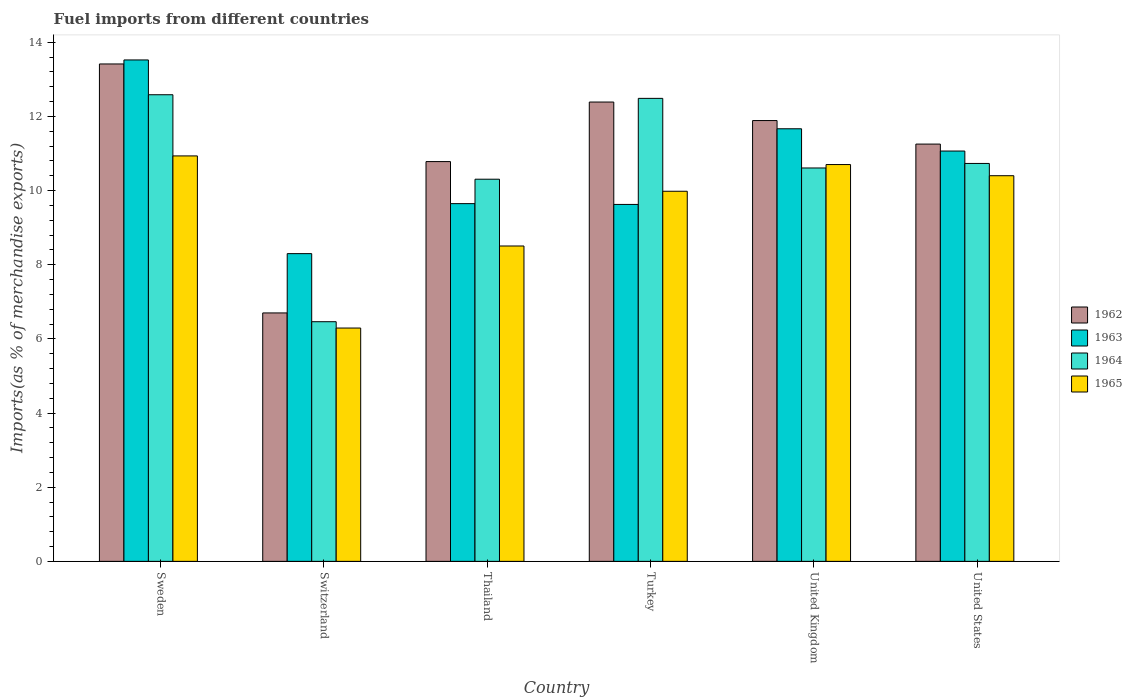How many different coloured bars are there?
Your response must be concise. 4. Are the number of bars per tick equal to the number of legend labels?
Keep it short and to the point. Yes. Are the number of bars on each tick of the X-axis equal?
Offer a terse response. Yes. How many bars are there on the 4th tick from the left?
Provide a short and direct response. 4. What is the label of the 6th group of bars from the left?
Your response must be concise. United States. What is the percentage of imports to different countries in 1965 in Turkey?
Keep it short and to the point. 9.98. Across all countries, what is the maximum percentage of imports to different countries in 1965?
Ensure brevity in your answer.  10.93. Across all countries, what is the minimum percentage of imports to different countries in 1964?
Offer a terse response. 6.46. In which country was the percentage of imports to different countries in 1962 minimum?
Offer a terse response. Switzerland. What is the total percentage of imports to different countries in 1964 in the graph?
Offer a terse response. 63.18. What is the difference between the percentage of imports to different countries in 1964 in Switzerland and that in Turkey?
Provide a short and direct response. -6.02. What is the difference between the percentage of imports to different countries in 1964 in Thailand and the percentage of imports to different countries in 1965 in United States?
Your answer should be compact. -0.09. What is the average percentage of imports to different countries in 1963 per country?
Your answer should be compact. 10.64. What is the difference between the percentage of imports to different countries of/in 1962 and percentage of imports to different countries of/in 1965 in Turkey?
Provide a succinct answer. 2.41. What is the ratio of the percentage of imports to different countries in 1962 in Switzerland to that in Turkey?
Provide a short and direct response. 0.54. Is the difference between the percentage of imports to different countries in 1962 in United Kingdom and United States greater than the difference between the percentage of imports to different countries in 1965 in United Kingdom and United States?
Make the answer very short. Yes. What is the difference between the highest and the second highest percentage of imports to different countries in 1965?
Give a very brief answer. -0.53. What is the difference between the highest and the lowest percentage of imports to different countries in 1962?
Your answer should be very brief. 6.72. Is the sum of the percentage of imports to different countries in 1965 in Sweden and United Kingdom greater than the maximum percentage of imports to different countries in 1963 across all countries?
Keep it short and to the point. Yes. What does the 2nd bar from the right in Thailand represents?
Give a very brief answer. 1964. Is it the case that in every country, the sum of the percentage of imports to different countries in 1964 and percentage of imports to different countries in 1965 is greater than the percentage of imports to different countries in 1963?
Offer a very short reply. Yes. How many bars are there?
Offer a terse response. 24. How many countries are there in the graph?
Give a very brief answer. 6. Are the values on the major ticks of Y-axis written in scientific E-notation?
Provide a short and direct response. No. Does the graph contain any zero values?
Your answer should be compact. No. Does the graph contain grids?
Ensure brevity in your answer.  No. How are the legend labels stacked?
Provide a short and direct response. Vertical. What is the title of the graph?
Provide a succinct answer. Fuel imports from different countries. Does "1997" appear as one of the legend labels in the graph?
Keep it short and to the point. No. What is the label or title of the X-axis?
Give a very brief answer. Country. What is the label or title of the Y-axis?
Your answer should be very brief. Imports(as % of merchandise exports). What is the Imports(as % of merchandise exports) of 1962 in Sweden?
Your response must be concise. 13.42. What is the Imports(as % of merchandise exports) in 1963 in Sweden?
Make the answer very short. 13.52. What is the Imports(as % of merchandise exports) in 1964 in Sweden?
Offer a very short reply. 12.58. What is the Imports(as % of merchandise exports) of 1965 in Sweden?
Offer a terse response. 10.93. What is the Imports(as % of merchandise exports) in 1962 in Switzerland?
Keep it short and to the point. 6.7. What is the Imports(as % of merchandise exports) of 1963 in Switzerland?
Ensure brevity in your answer.  8.3. What is the Imports(as % of merchandise exports) in 1964 in Switzerland?
Your answer should be very brief. 6.46. What is the Imports(as % of merchandise exports) in 1965 in Switzerland?
Provide a succinct answer. 6.29. What is the Imports(as % of merchandise exports) of 1962 in Thailand?
Provide a succinct answer. 10.78. What is the Imports(as % of merchandise exports) in 1963 in Thailand?
Your response must be concise. 9.65. What is the Imports(as % of merchandise exports) of 1964 in Thailand?
Your response must be concise. 10.31. What is the Imports(as % of merchandise exports) in 1965 in Thailand?
Ensure brevity in your answer.  8.51. What is the Imports(as % of merchandise exports) in 1962 in Turkey?
Keep it short and to the point. 12.39. What is the Imports(as % of merchandise exports) in 1963 in Turkey?
Offer a very short reply. 9.63. What is the Imports(as % of merchandise exports) of 1964 in Turkey?
Offer a terse response. 12.49. What is the Imports(as % of merchandise exports) of 1965 in Turkey?
Offer a very short reply. 9.98. What is the Imports(as % of merchandise exports) in 1962 in United Kingdom?
Offer a very short reply. 11.89. What is the Imports(as % of merchandise exports) of 1963 in United Kingdom?
Your response must be concise. 11.67. What is the Imports(as % of merchandise exports) of 1964 in United Kingdom?
Provide a succinct answer. 10.61. What is the Imports(as % of merchandise exports) in 1965 in United Kingdom?
Offer a very short reply. 10.7. What is the Imports(as % of merchandise exports) in 1962 in United States?
Your answer should be very brief. 11.25. What is the Imports(as % of merchandise exports) of 1963 in United States?
Your answer should be very brief. 11.07. What is the Imports(as % of merchandise exports) of 1964 in United States?
Make the answer very short. 10.73. What is the Imports(as % of merchandise exports) in 1965 in United States?
Offer a very short reply. 10.4. Across all countries, what is the maximum Imports(as % of merchandise exports) in 1962?
Provide a short and direct response. 13.42. Across all countries, what is the maximum Imports(as % of merchandise exports) of 1963?
Provide a short and direct response. 13.52. Across all countries, what is the maximum Imports(as % of merchandise exports) of 1964?
Make the answer very short. 12.58. Across all countries, what is the maximum Imports(as % of merchandise exports) in 1965?
Provide a succinct answer. 10.93. Across all countries, what is the minimum Imports(as % of merchandise exports) in 1962?
Give a very brief answer. 6.7. Across all countries, what is the minimum Imports(as % of merchandise exports) of 1963?
Provide a succinct answer. 8.3. Across all countries, what is the minimum Imports(as % of merchandise exports) in 1964?
Give a very brief answer. 6.46. Across all countries, what is the minimum Imports(as % of merchandise exports) of 1965?
Provide a short and direct response. 6.29. What is the total Imports(as % of merchandise exports) of 1962 in the graph?
Offer a terse response. 66.43. What is the total Imports(as % of merchandise exports) in 1963 in the graph?
Ensure brevity in your answer.  63.83. What is the total Imports(as % of merchandise exports) of 1964 in the graph?
Offer a terse response. 63.18. What is the total Imports(as % of merchandise exports) in 1965 in the graph?
Offer a very short reply. 56.82. What is the difference between the Imports(as % of merchandise exports) of 1962 in Sweden and that in Switzerland?
Give a very brief answer. 6.72. What is the difference between the Imports(as % of merchandise exports) of 1963 in Sweden and that in Switzerland?
Make the answer very short. 5.22. What is the difference between the Imports(as % of merchandise exports) of 1964 in Sweden and that in Switzerland?
Give a very brief answer. 6.12. What is the difference between the Imports(as % of merchandise exports) in 1965 in Sweden and that in Switzerland?
Your response must be concise. 4.64. What is the difference between the Imports(as % of merchandise exports) in 1962 in Sweden and that in Thailand?
Keep it short and to the point. 2.63. What is the difference between the Imports(as % of merchandise exports) in 1963 in Sweden and that in Thailand?
Your response must be concise. 3.88. What is the difference between the Imports(as % of merchandise exports) in 1964 in Sweden and that in Thailand?
Offer a terse response. 2.28. What is the difference between the Imports(as % of merchandise exports) of 1965 in Sweden and that in Thailand?
Provide a short and direct response. 2.43. What is the difference between the Imports(as % of merchandise exports) of 1962 in Sweden and that in Turkey?
Your response must be concise. 1.03. What is the difference between the Imports(as % of merchandise exports) in 1963 in Sweden and that in Turkey?
Your answer should be very brief. 3.9. What is the difference between the Imports(as % of merchandise exports) in 1964 in Sweden and that in Turkey?
Your response must be concise. 0.1. What is the difference between the Imports(as % of merchandise exports) in 1965 in Sweden and that in Turkey?
Your response must be concise. 0.95. What is the difference between the Imports(as % of merchandise exports) in 1962 in Sweden and that in United Kingdom?
Offer a terse response. 1.53. What is the difference between the Imports(as % of merchandise exports) in 1963 in Sweden and that in United Kingdom?
Offer a very short reply. 1.86. What is the difference between the Imports(as % of merchandise exports) of 1964 in Sweden and that in United Kingdom?
Your answer should be compact. 1.97. What is the difference between the Imports(as % of merchandise exports) in 1965 in Sweden and that in United Kingdom?
Make the answer very short. 0.23. What is the difference between the Imports(as % of merchandise exports) of 1962 in Sweden and that in United States?
Keep it short and to the point. 2.16. What is the difference between the Imports(as % of merchandise exports) in 1963 in Sweden and that in United States?
Your response must be concise. 2.46. What is the difference between the Imports(as % of merchandise exports) of 1964 in Sweden and that in United States?
Offer a terse response. 1.85. What is the difference between the Imports(as % of merchandise exports) of 1965 in Sweden and that in United States?
Your answer should be compact. 0.53. What is the difference between the Imports(as % of merchandise exports) in 1962 in Switzerland and that in Thailand?
Your answer should be very brief. -4.08. What is the difference between the Imports(as % of merchandise exports) in 1963 in Switzerland and that in Thailand?
Keep it short and to the point. -1.35. What is the difference between the Imports(as % of merchandise exports) in 1964 in Switzerland and that in Thailand?
Your answer should be very brief. -3.84. What is the difference between the Imports(as % of merchandise exports) of 1965 in Switzerland and that in Thailand?
Provide a short and direct response. -2.21. What is the difference between the Imports(as % of merchandise exports) in 1962 in Switzerland and that in Turkey?
Your answer should be very brief. -5.69. What is the difference between the Imports(as % of merchandise exports) of 1963 in Switzerland and that in Turkey?
Your answer should be compact. -1.33. What is the difference between the Imports(as % of merchandise exports) of 1964 in Switzerland and that in Turkey?
Your response must be concise. -6.02. What is the difference between the Imports(as % of merchandise exports) of 1965 in Switzerland and that in Turkey?
Your answer should be compact. -3.69. What is the difference between the Imports(as % of merchandise exports) of 1962 in Switzerland and that in United Kingdom?
Provide a short and direct response. -5.19. What is the difference between the Imports(as % of merchandise exports) in 1963 in Switzerland and that in United Kingdom?
Give a very brief answer. -3.37. What is the difference between the Imports(as % of merchandise exports) in 1964 in Switzerland and that in United Kingdom?
Make the answer very short. -4.15. What is the difference between the Imports(as % of merchandise exports) of 1965 in Switzerland and that in United Kingdom?
Offer a terse response. -4.41. What is the difference between the Imports(as % of merchandise exports) of 1962 in Switzerland and that in United States?
Your response must be concise. -4.55. What is the difference between the Imports(as % of merchandise exports) in 1963 in Switzerland and that in United States?
Ensure brevity in your answer.  -2.77. What is the difference between the Imports(as % of merchandise exports) of 1964 in Switzerland and that in United States?
Provide a short and direct response. -4.27. What is the difference between the Imports(as % of merchandise exports) of 1965 in Switzerland and that in United States?
Ensure brevity in your answer.  -4.11. What is the difference between the Imports(as % of merchandise exports) in 1962 in Thailand and that in Turkey?
Offer a very short reply. -1.61. What is the difference between the Imports(as % of merchandise exports) of 1963 in Thailand and that in Turkey?
Make the answer very short. 0.02. What is the difference between the Imports(as % of merchandise exports) of 1964 in Thailand and that in Turkey?
Ensure brevity in your answer.  -2.18. What is the difference between the Imports(as % of merchandise exports) in 1965 in Thailand and that in Turkey?
Provide a short and direct response. -1.48. What is the difference between the Imports(as % of merchandise exports) in 1962 in Thailand and that in United Kingdom?
Your response must be concise. -1.11. What is the difference between the Imports(as % of merchandise exports) in 1963 in Thailand and that in United Kingdom?
Offer a terse response. -2.02. What is the difference between the Imports(as % of merchandise exports) in 1964 in Thailand and that in United Kingdom?
Provide a short and direct response. -0.3. What is the difference between the Imports(as % of merchandise exports) of 1965 in Thailand and that in United Kingdom?
Ensure brevity in your answer.  -2.2. What is the difference between the Imports(as % of merchandise exports) of 1962 in Thailand and that in United States?
Offer a terse response. -0.47. What is the difference between the Imports(as % of merchandise exports) in 1963 in Thailand and that in United States?
Make the answer very short. -1.42. What is the difference between the Imports(as % of merchandise exports) in 1964 in Thailand and that in United States?
Offer a very short reply. -0.42. What is the difference between the Imports(as % of merchandise exports) of 1965 in Thailand and that in United States?
Provide a short and direct response. -1.9. What is the difference between the Imports(as % of merchandise exports) of 1962 in Turkey and that in United Kingdom?
Provide a succinct answer. 0.5. What is the difference between the Imports(as % of merchandise exports) of 1963 in Turkey and that in United Kingdom?
Make the answer very short. -2.04. What is the difference between the Imports(as % of merchandise exports) of 1964 in Turkey and that in United Kingdom?
Ensure brevity in your answer.  1.88. What is the difference between the Imports(as % of merchandise exports) in 1965 in Turkey and that in United Kingdom?
Your answer should be compact. -0.72. What is the difference between the Imports(as % of merchandise exports) in 1962 in Turkey and that in United States?
Give a very brief answer. 1.13. What is the difference between the Imports(as % of merchandise exports) in 1963 in Turkey and that in United States?
Your answer should be very brief. -1.44. What is the difference between the Imports(as % of merchandise exports) in 1964 in Turkey and that in United States?
Keep it short and to the point. 1.76. What is the difference between the Imports(as % of merchandise exports) of 1965 in Turkey and that in United States?
Your response must be concise. -0.42. What is the difference between the Imports(as % of merchandise exports) of 1962 in United Kingdom and that in United States?
Provide a succinct answer. 0.63. What is the difference between the Imports(as % of merchandise exports) in 1963 in United Kingdom and that in United States?
Offer a terse response. 0.6. What is the difference between the Imports(as % of merchandise exports) of 1964 in United Kingdom and that in United States?
Ensure brevity in your answer.  -0.12. What is the difference between the Imports(as % of merchandise exports) of 1965 in United Kingdom and that in United States?
Provide a short and direct response. 0.3. What is the difference between the Imports(as % of merchandise exports) of 1962 in Sweden and the Imports(as % of merchandise exports) of 1963 in Switzerland?
Make the answer very short. 5.12. What is the difference between the Imports(as % of merchandise exports) in 1962 in Sweden and the Imports(as % of merchandise exports) in 1964 in Switzerland?
Keep it short and to the point. 6.95. What is the difference between the Imports(as % of merchandise exports) in 1962 in Sweden and the Imports(as % of merchandise exports) in 1965 in Switzerland?
Make the answer very short. 7.12. What is the difference between the Imports(as % of merchandise exports) of 1963 in Sweden and the Imports(as % of merchandise exports) of 1964 in Switzerland?
Give a very brief answer. 7.06. What is the difference between the Imports(as % of merchandise exports) of 1963 in Sweden and the Imports(as % of merchandise exports) of 1965 in Switzerland?
Provide a succinct answer. 7.23. What is the difference between the Imports(as % of merchandise exports) in 1964 in Sweden and the Imports(as % of merchandise exports) in 1965 in Switzerland?
Your answer should be compact. 6.29. What is the difference between the Imports(as % of merchandise exports) of 1962 in Sweden and the Imports(as % of merchandise exports) of 1963 in Thailand?
Provide a short and direct response. 3.77. What is the difference between the Imports(as % of merchandise exports) in 1962 in Sweden and the Imports(as % of merchandise exports) in 1964 in Thailand?
Your response must be concise. 3.11. What is the difference between the Imports(as % of merchandise exports) in 1962 in Sweden and the Imports(as % of merchandise exports) in 1965 in Thailand?
Offer a very short reply. 4.91. What is the difference between the Imports(as % of merchandise exports) in 1963 in Sweden and the Imports(as % of merchandise exports) in 1964 in Thailand?
Offer a terse response. 3.22. What is the difference between the Imports(as % of merchandise exports) of 1963 in Sweden and the Imports(as % of merchandise exports) of 1965 in Thailand?
Offer a very short reply. 5.02. What is the difference between the Imports(as % of merchandise exports) of 1964 in Sweden and the Imports(as % of merchandise exports) of 1965 in Thailand?
Your answer should be very brief. 4.08. What is the difference between the Imports(as % of merchandise exports) of 1962 in Sweden and the Imports(as % of merchandise exports) of 1963 in Turkey?
Your answer should be compact. 3.79. What is the difference between the Imports(as % of merchandise exports) of 1962 in Sweden and the Imports(as % of merchandise exports) of 1964 in Turkey?
Provide a short and direct response. 0.93. What is the difference between the Imports(as % of merchandise exports) in 1962 in Sweden and the Imports(as % of merchandise exports) in 1965 in Turkey?
Keep it short and to the point. 3.43. What is the difference between the Imports(as % of merchandise exports) of 1963 in Sweden and the Imports(as % of merchandise exports) of 1964 in Turkey?
Your answer should be very brief. 1.04. What is the difference between the Imports(as % of merchandise exports) in 1963 in Sweden and the Imports(as % of merchandise exports) in 1965 in Turkey?
Provide a short and direct response. 3.54. What is the difference between the Imports(as % of merchandise exports) of 1964 in Sweden and the Imports(as % of merchandise exports) of 1965 in Turkey?
Provide a succinct answer. 2.6. What is the difference between the Imports(as % of merchandise exports) of 1962 in Sweden and the Imports(as % of merchandise exports) of 1963 in United Kingdom?
Your answer should be compact. 1.75. What is the difference between the Imports(as % of merchandise exports) of 1962 in Sweden and the Imports(as % of merchandise exports) of 1964 in United Kingdom?
Provide a short and direct response. 2.81. What is the difference between the Imports(as % of merchandise exports) in 1962 in Sweden and the Imports(as % of merchandise exports) in 1965 in United Kingdom?
Ensure brevity in your answer.  2.71. What is the difference between the Imports(as % of merchandise exports) of 1963 in Sweden and the Imports(as % of merchandise exports) of 1964 in United Kingdom?
Offer a very short reply. 2.91. What is the difference between the Imports(as % of merchandise exports) of 1963 in Sweden and the Imports(as % of merchandise exports) of 1965 in United Kingdom?
Your answer should be very brief. 2.82. What is the difference between the Imports(as % of merchandise exports) of 1964 in Sweden and the Imports(as % of merchandise exports) of 1965 in United Kingdom?
Offer a very short reply. 1.88. What is the difference between the Imports(as % of merchandise exports) in 1962 in Sweden and the Imports(as % of merchandise exports) in 1963 in United States?
Your answer should be compact. 2.35. What is the difference between the Imports(as % of merchandise exports) of 1962 in Sweden and the Imports(as % of merchandise exports) of 1964 in United States?
Keep it short and to the point. 2.68. What is the difference between the Imports(as % of merchandise exports) in 1962 in Sweden and the Imports(as % of merchandise exports) in 1965 in United States?
Provide a short and direct response. 3.01. What is the difference between the Imports(as % of merchandise exports) in 1963 in Sweden and the Imports(as % of merchandise exports) in 1964 in United States?
Provide a succinct answer. 2.79. What is the difference between the Imports(as % of merchandise exports) in 1963 in Sweden and the Imports(as % of merchandise exports) in 1965 in United States?
Provide a short and direct response. 3.12. What is the difference between the Imports(as % of merchandise exports) in 1964 in Sweden and the Imports(as % of merchandise exports) in 1965 in United States?
Provide a succinct answer. 2.18. What is the difference between the Imports(as % of merchandise exports) of 1962 in Switzerland and the Imports(as % of merchandise exports) of 1963 in Thailand?
Keep it short and to the point. -2.95. What is the difference between the Imports(as % of merchandise exports) in 1962 in Switzerland and the Imports(as % of merchandise exports) in 1964 in Thailand?
Provide a short and direct response. -3.61. What is the difference between the Imports(as % of merchandise exports) in 1962 in Switzerland and the Imports(as % of merchandise exports) in 1965 in Thailand?
Offer a very short reply. -1.81. What is the difference between the Imports(as % of merchandise exports) in 1963 in Switzerland and the Imports(as % of merchandise exports) in 1964 in Thailand?
Keep it short and to the point. -2.01. What is the difference between the Imports(as % of merchandise exports) in 1963 in Switzerland and the Imports(as % of merchandise exports) in 1965 in Thailand?
Your response must be concise. -0.21. What is the difference between the Imports(as % of merchandise exports) of 1964 in Switzerland and the Imports(as % of merchandise exports) of 1965 in Thailand?
Your response must be concise. -2.04. What is the difference between the Imports(as % of merchandise exports) in 1962 in Switzerland and the Imports(as % of merchandise exports) in 1963 in Turkey?
Your answer should be compact. -2.93. What is the difference between the Imports(as % of merchandise exports) in 1962 in Switzerland and the Imports(as % of merchandise exports) in 1964 in Turkey?
Give a very brief answer. -5.79. What is the difference between the Imports(as % of merchandise exports) in 1962 in Switzerland and the Imports(as % of merchandise exports) in 1965 in Turkey?
Keep it short and to the point. -3.28. What is the difference between the Imports(as % of merchandise exports) of 1963 in Switzerland and the Imports(as % of merchandise exports) of 1964 in Turkey?
Your answer should be very brief. -4.19. What is the difference between the Imports(as % of merchandise exports) of 1963 in Switzerland and the Imports(as % of merchandise exports) of 1965 in Turkey?
Offer a very short reply. -1.68. What is the difference between the Imports(as % of merchandise exports) in 1964 in Switzerland and the Imports(as % of merchandise exports) in 1965 in Turkey?
Your response must be concise. -3.52. What is the difference between the Imports(as % of merchandise exports) in 1962 in Switzerland and the Imports(as % of merchandise exports) in 1963 in United Kingdom?
Ensure brevity in your answer.  -4.97. What is the difference between the Imports(as % of merchandise exports) of 1962 in Switzerland and the Imports(as % of merchandise exports) of 1964 in United Kingdom?
Offer a very short reply. -3.91. What is the difference between the Imports(as % of merchandise exports) of 1962 in Switzerland and the Imports(as % of merchandise exports) of 1965 in United Kingdom?
Provide a succinct answer. -4. What is the difference between the Imports(as % of merchandise exports) of 1963 in Switzerland and the Imports(as % of merchandise exports) of 1964 in United Kingdom?
Make the answer very short. -2.31. What is the difference between the Imports(as % of merchandise exports) in 1963 in Switzerland and the Imports(as % of merchandise exports) in 1965 in United Kingdom?
Keep it short and to the point. -2.4. What is the difference between the Imports(as % of merchandise exports) in 1964 in Switzerland and the Imports(as % of merchandise exports) in 1965 in United Kingdom?
Give a very brief answer. -4.24. What is the difference between the Imports(as % of merchandise exports) in 1962 in Switzerland and the Imports(as % of merchandise exports) in 1963 in United States?
Make the answer very short. -4.37. What is the difference between the Imports(as % of merchandise exports) of 1962 in Switzerland and the Imports(as % of merchandise exports) of 1964 in United States?
Provide a succinct answer. -4.03. What is the difference between the Imports(as % of merchandise exports) in 1962 in Switzerland and the Imports(as % of merchandise exports) in 1965 in United States?
Provide a short and direct response. -3.7. What is the difference between the Imports(as % of merchandise exports) in 1963 in Switzerland and the Imports(as % of merchandise exports) in 1964 in United States?
Provide a short and direct response. -2.43. What is the difference between the Imports(as % of merchandise exports) in 1963 in Switzerland and the Imports(as % of merchandise exports) in 1965 in United States?
Ensure brevity in your answer.  -2.1. What is the difference between the Imports(as % of merchandise exports) in 1964 in Switzerland and the Imports(as % of merchandise exports) in 1965 in United States?
Your answer should be compact. -3.94. What is the difference between the Imports(as % of merchandise exports) of 1962 in Thailand and the Imports(as % of merchandise exports) of 1963 in Turkey?
Keep it short and to the point. 1.16. What is the difference between the Imports(as % of merchandise exports) in 1962 in Thailand and the Imports(as % of merchandise exports) in 1964 in Turkey?
Provide a succinct answer. -1.71. What is the difference between the Imports(as % of merchandise exports) in 1962 in Thailand and the Imports(as % of merchandise exports) in 1965 in Turkey?
Keep it short and to the point. 0.8. What is the difference between the Imports(as % of merchandise exports) in 1963 in Thailand and the Imports(as % of merchandise exports) in 1964 in Turkey?
Offer a terse response. -2.84. What is the difference between the Imports(as % of merchandise exports) of 1963 in Thailand and the Imports(as % of merchandise exports) of 1965 in Turkey?
Your response must be concise. -0.33. What is the difference between the Imports(as % of merchandise exports) in 1964 in Thailand and the Imports(as % of merchandise exports) in 1965 in Turkey?
Ensure brevity in your answer.  0.32. What is the difference between the Imports(as % of merchandise exports) in 1962 in Thailand and the Imports(as % of merchandise exports) in 1963 in United Kingdom?
Offer a very short reply. -0.89. What is the difference between the Imports(as % of merchandise exports) of 1962 in Thailand and the Imports(as % of merchandise exports) of 1964 in United Kingdom?
Provide a succinct answer. 0.17. What is the difference between the Imports(as % of merchandise exports) in 1962 in Thailand and the Imports(as % of merchandise exports) in 1965 in United Kingdom?
Keep it short and to the point. 0.08. What is the difference between the Imports(as % of merchandise exports) of 1963 in Thailand and the Imports(as % of merchandise exports) of 1964 in United Kingdom?
Offer a terse response. -0.96. What is the difference between the Imports(as % of merchandise exports) of 1963 in Thailand and the Imports(as % of merchandise exports) of 1965 in United Kingdom?
Provide a succinct answer. -1.05. What is the difference between the Imports(as % of merchandise exports) in 1964 in Thailand and the Imports(as % of merchandise exports) in 1965 in United Kingdom?
Provide a short and direct response. -0.4. What is the difference between the Imports(as % of merchandise exports) of 1962 in Thailand and the Imports(as % of merchandise exports) of 1963 in United States?
Ensure brevity in your answer.  -0.28. What is the difference between the Imports(as % of merchandise exports) in 1962 in Thailand and the Imports(as % of merchandise exports) in 1964 in United States?
Provide a succinct answer. 0.05. What is the difference between the Imports(as % of merchandise exports) of 1962 in Thailand and the Imports(as % of merchandise exports) of 1965 in United States?
Your response must be concise. 0.38. What is the difference between the Imports(as % of merchandise exports) of 1963 in Thailand and the Imports(as % of merchandise exports) of 1964 in United States?
Offer a very short reply. -1.08. What is the difference between the Imports(as % of merchandise exports) in 1963 in Thailand and the Imports(as % of merchandise exports) in 1965 in United States?
Provide a succinct answer. -0.75. What is the difference between the Imports(as % of merchandise exports) of 1964 in Thailand and the Imports(as % of merchandise exports) of 1965 in United States?
Provide a succinct answer. -0.09. What is the difference between the Imports(as % of merchandise exports) of 1962 in Turkey and the Imports(as % of merchandise exports) of 1963 in United Kingdom?
Offer a very short reply. 0.72. What is the difference between the Imports(as % of merchandise exports) of 1962 in Turkey and the Imports(as % of merchandise exports) of 1964 in United Kingdom?
Keep it short and to the point. 1.78. What is the difference between the Imports(as % of merchandise exports) in 1962 in Turkey and the Imports(as % of merchandise exports) in 1965 in United Kingdom?
Make the answer very short. 1.69. What is the difference between the Imports(as % of merchandise exports) of 1963 in Turkey and the Imports(as % of merchandise exports) of 1964 in United Kingdom?
Your response must be concise. -0.98. What is the difference between the Imports(as % of merchandise exports) of 1963 in Turkey and the Imports(as % of merchandise exports) of 1965 in United Kingdom?
Your answer should be compact. -1.08. What is the difference between the Imports(as % of merchandise exports) in 1964 in Turkey and the Imports(as % of merchandise exports) in 1965 in United Kingdom?
Your answer should be very brief. 1.78. What is the difference between the Imports(as % of merchandise exports) in 1962 in Turkey and the Imports(as % of merchandise exports) in 1963 in United States?
Offer a terse response. 1.32. What is the difference between the Imports(as % of merchandise exports) of 1962 in Turkey and the Imports(as % of merchandise exports) of 1964 in United States?
Offer a terse response. 1.66. What is the difference between the Imports(as % of merchandise exports) in 1962 in Turkey and the Imports(as % of merchandise exports) in 1965 in United States?
Your answer should be compact. 1.99. What is the difference between the Imports(as % of merchandise exports) of 1963 in Turkey and the Imports(as % of merchandise exports) of 1964 in United States?
Provide a short and direct response. -1.11. What is the difference between the Imports(as % of merchandise exports) of 1963 in Turkey and the Imports(as % of merchandise exports) of 1965 in United States?
Keep it short and to the point. -0.77. What is the difference between the Imports(as % of merchandise exports) in 1964 in Turkey and the Imports(as % of merchandise exports) in 1965 in United States?
Keep it short and to the point. 2.09. What is the difference between the Imports(as % of merchandise exports) of 1962 in United Kingdom and the Imports(as % of merchandise exports) of 1963 in United States?
Offer a terse response. 0.82. What is the difference between the Imports(as % of merchandise exports) in 1962 in United Kingdom and the Imports(as % of merchandise exports) in 1964 in United States?
Make the answer very short. 1.16. What is the difference between the Imports(as % of merchandise exports) in 1962 in United Kingdom and the Imports(as % of merchandise exports) in 1965 in United States?
Give a very brief answer. 1.49. What is the difference between the Imports(as % of merchandise exports) in 1963 in United Kingdom and the Imports(as % of merchandise exports) in 1964 in United States?
Provide a short and direct response. 0.94. What is the difference between the Imports(as % of merchandise exports) of 1963 in United Kingdom and the Imports(as % of merchandise exports) of 1965 in United States?
Make the answer very short. 1.27. What is the difference between the Imports(as % of merchandise exports) of 1964 in United Kingdom and the Imports(as % of merchandise exports) of 1965 in United States?
Offer a terse response. 0.21. What is the average Imports(as % of merchandise exports) of 1962 per country?
Your answer should be very brief. 11.07. What is the average Imports(as % of merchandise exports) in 1963 per country?
Provide a short and direct response. 10.64. What is the average Imports(as % of merchandise exports) of 1964 per country?
Your answer should be very brief. 10.53. What is the average Imports(as % of merchandise exports) in 1965 per country?
Make the answer very short. 9.47. What is the difference between the Imports(as % of merchandise exports) in 1962 and Imports(as % of merchandise exports) in 1963 in Sweden?
Your answer should be very brief. -0.11. What is the difference between the Imports(as % of merchandise exports) in 1962 and Imports(as % of merchandise exports) in 1964 in Sweden?
Offer a terse response. 0.83. What is the difference between the Imports(as % of merchandise exports) in 1962 and Imports(as % of merchandise exports) in 1965 in Sweden?
Offer a terse response. 2.48. What is the difference between the Imports(as % of merchandise exports) of 1963 and Imports(as % of merchandise exports) of 1964 in Sweden?
Your answer should be very brief. 0.94. What is the difference between the Imports(as % of merchandise exports) in 1963 and Imports(as % of merchandise exports) in 1965 in Sweden?
Your answer should be compact. 2.59. What is the difference between the Imports(as % of merchandise exports) of 1964 and Imports(as % of merchandise exports) of 1965 in Sweden?
Keep it short and to the point. 1.65. What is the difference between the Imports(as % of merchandise exports) of 1962 and Imports(as % of merchandise exports) of 1963 in Switzerland?
Provide a succinct answer. -1.6. What is the difference between the Imports(as % of merchandise exports) of 1962 and Imports(as % of merchandise exports) of 1964 in Switzerland?
Provide a short and direct response. 0.24. What is the difference between the Imports(as % of merchandise exports) of 1962 and Imports(as % of merchandise exports) of 1965 in Switzerland?
Make the answer very short. 0.41. What is the difference between the Imports(as % of merchandise exports) of 1963 and Imports(as % of merchandise exports) of 1964 in Switzerland?
Keep it short and to the point. 1.84. What is the difference between the Imports(as % of merchandise exports) in 1963 and Imports(as % of merchandise exports) in 1965 in Switzerland?
Offer a very short reply. 2.01. What is the difference between the Imports(as % of merchandise exports) of 1964 and Imports(as % of merchandise exports) of 1965 in Switzerland?
Offer a terse response. 0.17. What is the difference between the Imports(as % of merchandise exports) in 1962 and Imports(as % of merchandise exports) in 1963 in Thailand?
Provide a short and direct response. 1.13. What is the difference between the Imports(as % of merchandise exports) of 1962 and Imports(as % of merchandise exports) of 1964 in Thailand?
Provide a short and direct response. 0.48. What is the difference between the Imports(as % of merchandise exports) of 1962 and Imports(as % of merchandise exports) of 1965 in Thailand?
Your answer should be very brief. 2.28. What is the difference between the Imports(as % of merchandise exports) of 1963 and Imports(as % of merchandise exports) of 1964 in Thailand?
Ensure brevity in your answer.  -0.66. What is the difference between the Imports(as % of merchandise exports) in 1963 and Imports(as % of merchandise exports) in 1965 in Thailand?
Offer a very short reply. 1.14. What is the difference between the Imports(as % of merchandise exports) of 1964 and Imports(as % of merchandise exports) of 1965 in Thailand?
Provide a succinct answer. 1.8. What is the difference between the Imports(as % of merchandise exports) of 1962 and Imports(as % of merchandise exports) of 1963 in Turkey?
Give a very brief answer. 2.76. What is the difference between the Imports(as % of merchandise exports) of 1962 and Imports(as % of merchandise exports) of 1964 in Turkey?
Your response must be concise. -0.1. What is the difference between the Imports(as % of merchandise exports) in 1962 and Imports(as % of merchandise exports) in 1965 in Turkey?
Provide a short and direct response. 2.41. What is the difference between the Imports(as % of merchandise exports) in 1963 and Imports(as % of merchandise exports) in 1964 in Turkey?
Keep it short and to the point. -2.86. What is the difference between the Imports(as % of merchandise exports) of 1963 and Imports(as % of merchandise exports) of 1965 in Turkey?
Provide a short and direct response. -0.36. What is the difference between the Imports(as % of merchandise exports) of 1964 and Imports(as % of merchandise exports) of 1965 in Turkey?
Your response must be concise. 2.51. What is the difference between the Imports(as % of merchandise exports) of 1962 and Imports(as % of merchandise exports) of 1963 in United Kingdom?
Your answer should be very brief. 0.22. What is the difference between the Imports(as % of merchandise exports) in 1962 and Imports(as % of merchandise exports) in 1964 in United Kingdom?
Make the answer very short. 1.28. What is the difference between the Imports(as % of merchandise exports) of 1962 and Imports(as % of merchandise exports) of 1965 in United Kingdom?
Keep it short and to the point. 1.19. What is the difference between the Imports(as % of merchandise exports) in 1963 and Imports(as % of merchandise exports) in 1964 in United Kingdom?
Make the answer very short. 1.06. What is the difference between the Imports(as % of merchandise exports) of 1964 and Imports(as % of merchandise exports) of 1965 in United Kingdom?
Offer a very short reply. -0.09. What is the difference between the Imports(as % of merchandise exports) in 1962 and Imports(as % of merchandise exports) in 1963 in United States?
Ensure brevity in your answer.  0.19. What is the difference between the Imports(as % of merchandise exports) in 1962 and Imports(as % of merchandise exports) in 1964 in United States?
Your response must be concise. 0.52. What is the difference between the Imports(as % of merchandise exports) of 1962 and Imports(as % of merchandise exports) of 1965 in United States?
Ensure brevity in your answer.  0.85. What is the difference between the Imports(as % of merchandise exports) in 1963 and Imports(as % of merchandise exports) in 1964 in United States?
Ensure brevity in your answer.  0.33. What is the difference between the Imports(as % of merchandise exports) in 1963 and Imports(as % of merchandise exports) in 1965 in United States?
Offer a terse response. 0.67. What is the difference between the Imports(as % of merchandise exports) of 1964 and Imports(as % of merchandise exports) of 1965 in United States?
Provide a succinct answer. 0.33. What is the ratio of the Imports(as % of merchandise exports) in 1962 in Sweden to that in Switzerland?
Provide a short and direct response. 2. What is the ratio of the Imports(as % of merchandise exports) of 1963 in Sweden to that in Switzerland?
Your answer should be compact. 1.63. What is the ratio of the Imports(as % of merchandise exports) in 1964 in Sweden to that in Switzerland?
Offer a very short reply. 1.95. What is the ratio of the Imports(as % of merchandise exports) in 1965 in Sweden to that in Switzerland?
Ensure brevity in your answer.  1.74. What is the ratio of the Imports(as % of merchandise exports) of 1962 in Sweden to that in Thailand?
Keep it short and to the point. 1.24. What is the ratio of the Imports(as % of merchandise exports) of 1963 in Sweden to that in Thailand?
Offer a terse response. 1.4. What is the ratio of the Imports(as % of merchandise exports) in 1964 in Sweden to that in Thailand?
Your answer should be compact. 1.22. What is the ratio of the Imports(as % of merchandise exports) in 1965 in Sweden to that in Thailand?
Provide a short and direct response. 1.29. What is the ratio of the Imports(as % of merchandise exports) in 1962 in Sweden to that in Turkey?
Provide a succinct answer. 1.08. What is the ratio of the Imports(as % of merchandise exports) of 1963 in Sweden to that in Turkey?
Ensure brevity in your answer.  1.4. What is the ratio of the Imports(as % of merchandise exports) in 1964 in Sweden to that in Turkey?
Provide a short and direct response. 1.01. What is the ratio of the Imports(as % of merchandise exports) of 1965 in Sweden to that in Turkey?
Give a very brief answer. 1.1. What is the ratio of the Imports(as % of merchandise exports) of 1962 in Sweden to that in United Kingdom?
Give a very brief answer. 1.13. What is the ratio of the Imports(as % of merchandise exports) of 1963 in Sweden to that in United Kingdom?
Give a very brief answer. 1.16. What is the ratio of the Imports(as % of merchandise exports) in 1964 in Sweden to that in United Kingdom?
Provide a short and direct response. 1.19. What is the ratio of the Imports(as % of merchandise exports) in 1965 in Sweden to that in United Kingdom?
Provide a short and direct response. 1.02. What is the ratio of the Imports(as % of merchandise exports) of 1962 in Sweden to that in United States?
Keep it short and to the point. 1.19. What is the ratio of the Imports(as % of merchandise exports) of 1963 in Sweden to that in United States?
Offer a very short reply. 1.22. What is the ratio of the Imports(as % of merchandise exports) in 1964 in Sweden to that in United States?
Make the answer very short. 1.17. What is the ratio of the Imports(as % of merchandise exports) of 1965 in Sweden to that in United States?
Keep it short and to the point. 1.05. What is the ratio of the Imports(as % of merchandise exports) in 1962 in Switzerland to that in Thailand?
Offer a very short reply. 0.62. What is the ratio of the Imports(as % of merchandise exports) of 1963 in Switzerland to that in Thailand?
Ensure brevity in your answer.  0.86. What is the ratio of the Imports(as % of merchandise exports) of 1964 in Switzerland to that in Thailand?
Provide a succinct answer. 0.63. What is the ratio of the Imports(as % of merchandise exports) of 1965 in Switzerland to that in Thailand?
Offer a very short reply. 0.74. What is the ratio of the Imports(as % of merchandise exports) in 1962 in Switzerland to that in Turkey?
Give a very brief answer. 0.54. What is the ratio of the Imports(as % of merchandise exports) of 1963 in Switzerland to that in Turkey?
Your response must be concise. 0.86. What is the ratio of the Imports(as % of merchandise exports) in 1964 in Switzerland to that in Turkey?
Your response must be concise. 0.52. What is the ratio of the Imports(as % of merchandise exports) of 1965 in Switzerland to that in Turkey?
Give a very brief answer. 0.63. What is the ratio of the Imports(as % of merchandise exports) of 1962 in Switzerland to that in United Kingdom?
Provide a short and direct response. 0.56. What is the ratio of the Imports(as % of merchandise exports) of 1963 in Switzerland to that in United Kingdom?
Your response must be concise. 0.71. What is the ratio of the Imports(as % of merchandise exports) in 1964 in Switzerland to that in United Kingdom?
Offer a terse response. 0.61. What is the ratio of the Imports(as % of merchandise exports) of 1965 in Switzerland to that in United Kingdom?
Offer a terse response. 0.59. What is the ratio of the Imports(as % of merchandise exports) of 1962 in Switzerland to that in United States?
Your response must be concise. 0.6. What is the ratio of the Imports(as % of merchandise exports) of 1963 in Switzerland to that in United States?
Your response must be concise. 0.75. What is the ratio of the Imports(as % of merchandise exports) of 1964 in Switzerland to that in United States?
Offer a very short reply. 0.6. What is the ratio of the Imports(as % of merchandise exports) of 1965 in Switzerland to that in United States?
Your answer should be very brief. 0.6. What is the ratio of the Imports(as % of merchandise exports) in 1962 in Thailand to that in Turkey?
Make the answer very short. 0.87. What is the ratio of the Imports(as % of merchandise exports) in 1964 in Thailand to that in Turkey?
Provide a short and direct response. 0.83. What is the ratio of the Imports(as % of merchandise exports) in 1965 in Thailand to that in Turkey?
Provide a succinct answer. 0.85. What is the ratio of the Imports(as % of merchandise exports) in 1962 in Thailand to that in United Kingdom?
Make the answer very short. 0.91. What is the ratio of the Imports(as % of merchandise exports) in 1963 in Thailand to that in United Kingdom?
Offer a very short reply. 0.83. What is the ratio of the Imports(as % of merchandise exports) of 1964 in Thailand to that in United Kingdom?
Provide a short and direct response. 0.97. What is the ratio of the Imports(as % of merchandise exports) in 1965 in Thailand to that in United Kingdom?
Ensure brevity in your answer.  0.79. What is the ratio of the Imports(as % of merchandise exports) in 1962 in Thailand to that in United States?
Your answer should be compact. 0.96. What is the ratio of the Imports(as % of merchandise exports) in 1963 in Thailand to that in United States?
Provide a short and direct response. 0.87. What is the ratio of the Imports(as % of merchandise exports) of 1964 in Thailand to that in United States?
Give a very brief answer. 0.96. What is the ratio of the Imports(as % of merchandise exports) in 1965 in Thailand to that in United States?
Provide a short and direct response. 0.82. What is the ratio of the Imports(as % of merchandise exports) in 1962 in Turkey to that in United Kingdom?
Give a very brief answer. 1.04. What is the ratio of the Imports(as % of merchandise exports) of 1963 in Turkey to that in United Kingdom?
Make the answer very short. 0.83. What is the ratio of the Imports(as % of merchandise exports) in 1964 in Turkey to that in United Kingdom?
Your answer should be compact. 1.18. What is the ratio of the Imports(as % of merchandise exports) in 1965 in Turkey to that in United Kingdom?
Provide a succinct answer. 0.93. What is the ratio of the Imports(as % of merchandise exports) in 1962 in Turkey to that in United States?
Make the answer very short. 1.1. What is the ratio of the Imports(as % of merchandise exports) in 1963 in Turkey to that in United States?
Give a very brief answer. 0.87. What is the ratio of the Imports(as % of merchandise exports) in 1964 in Turkey to that in United States?
Offer a terse response. 1.16. What is the ratio of the Imports(as % of merchandise exports) in 1965 in Turkey to that in United States?
Provide a succinct answer. 0.96. What is the ratio of the Imports(as % of merchandise exports) of 1962 in United Kingdom to that in United States?
Your answer should be very brief. 1.06. What is the ratio of the Imports(as % of merchandise exports) in 1963 in United Kingdom to that in United States?
Ensure brevity in your answer.  1.05. What is the ratio of the Imports(as % of merchandise exports) in 1964 in United Kingdom to that in United States?
Ensure brevity in your answer.  0.99. What is the ratio of the Imports(as % of merchandise exports) of 1965 in United Kingdom to that in United States?
Ensure brevity in your answer.  1.03. What is the difference between the highest and the second highest Imports(as % of merchandise exports) of 1962?
Your answer should be very brief. 1.03. What is the difference between the highest and the second highest Imports(as % of merchandise exports) in 1963?
Give a very brief answer. 1.86. What is the difference between the highest and the second highest Imports(as % of merchandise exports) in 1964?
Provide a short and direct response. 0.1. What is the difference between the highest and the second highest Imports(as % of merchandise exports) in 1965?
Offer a terse response. 0.23. What is the difference between the highest and the lowest Imports(as % of merchandise exports) in 1962?
Offer a very short reply. 6.72. What is the difference between the highest and the lowest Imports(as % of merchandise exports) of 1963?
Provide a succinct answer. 5.22. What is the difference between the highest and the lowest Imports(as % of merchandise exports) of 1964?
Offer a very short reply. 6.12. What is the difference between the highest and the lowest Imports(as % of merchandise exports) in 1965?
Your answer should be compact. 4.64. 